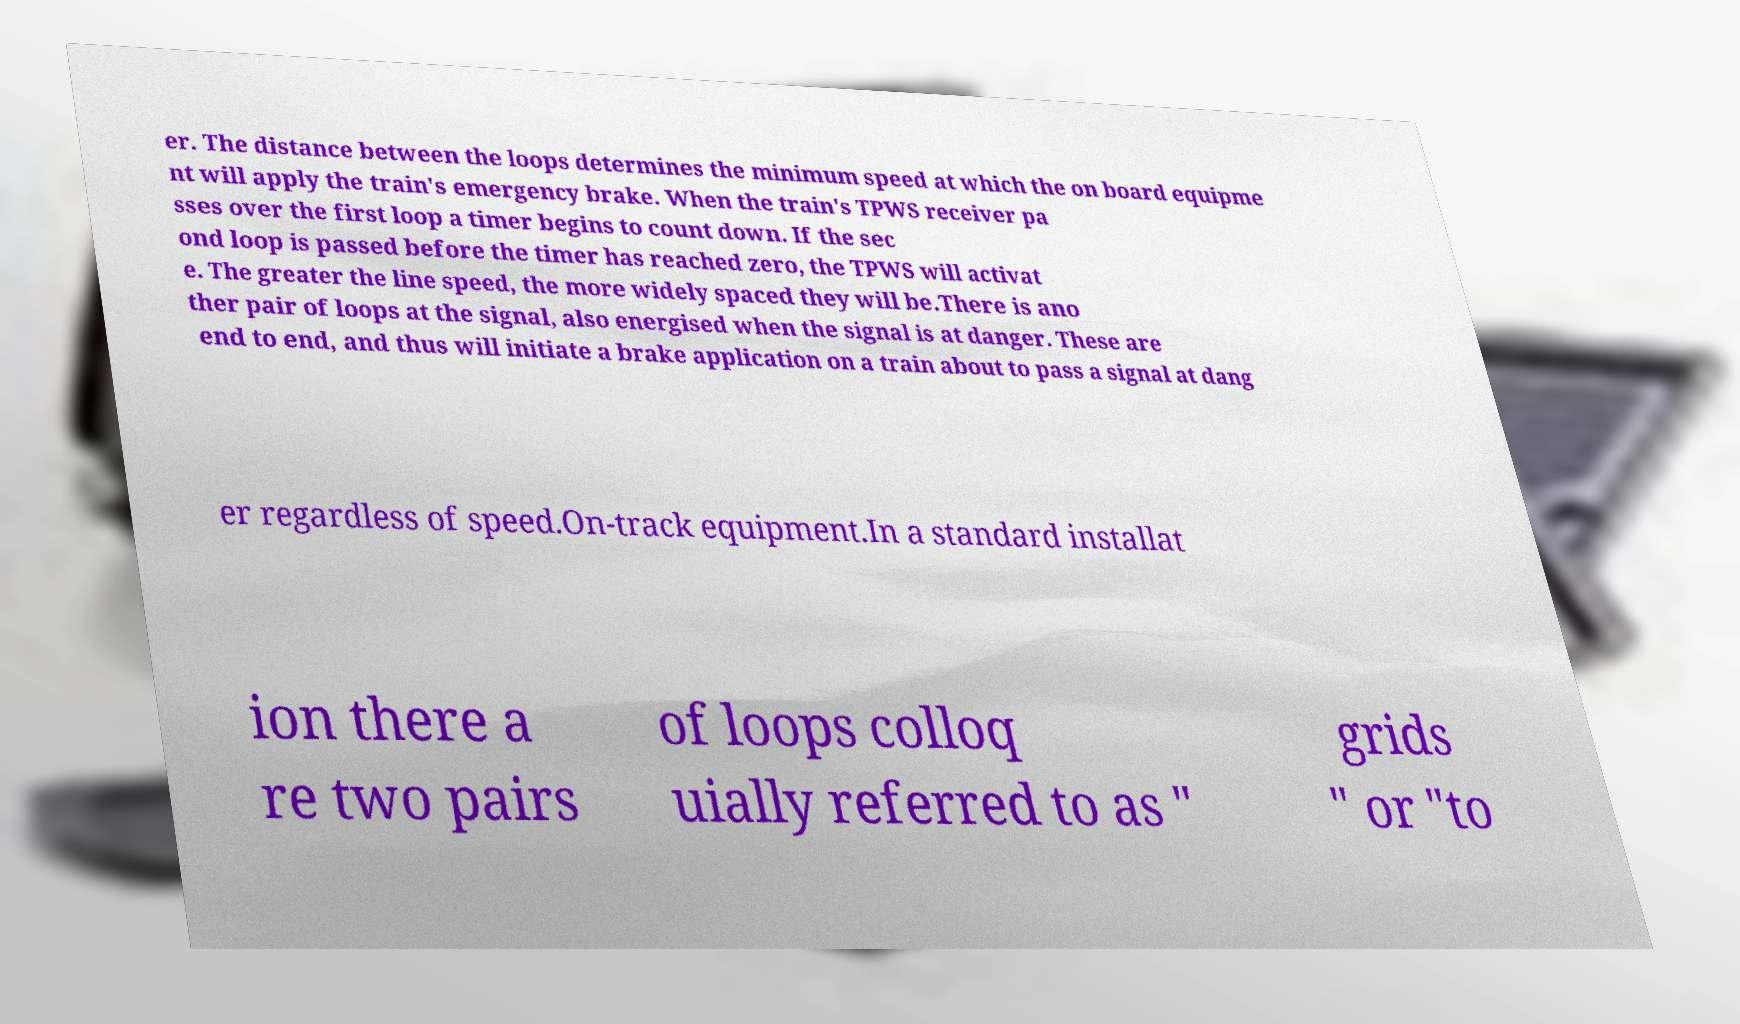Could you assist in decoding the text presented in this image and type it out clearly? er. The distance between the loops determines the minimum speed at which the on board equipme nt will apply the train's emergency brake. When the train's TPWS receiver pa sses over the first loop a timer begins to count down. If the sec ond loop is passed before the timer has reached zero, the TPWS will activat e. The greater the line speed, the more widely spaced they will be.There is ano ther pair of loops at the signal, also energised when the signal is at danger. These are end to end, and thus will initiate a brake application on a train about to pass a signal at dang er regardless of speed.On-track equipment.In a standard installat ion there a re two pairs of loops colloq uially referred to as " grids " or "to 